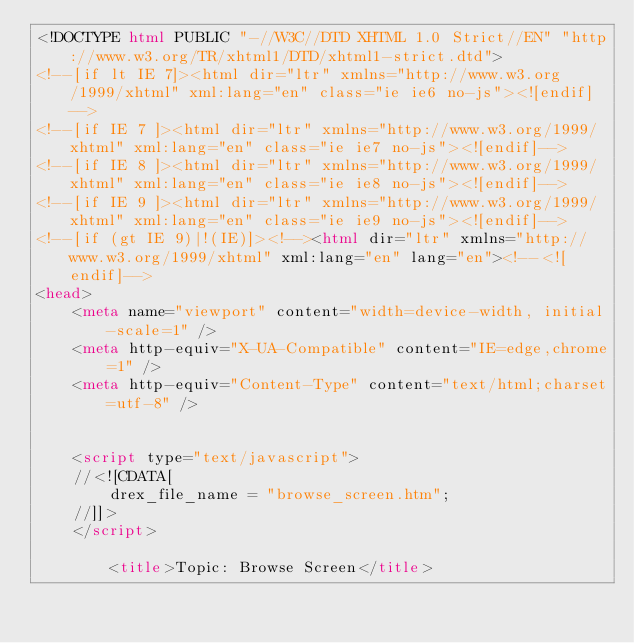Convert code to text. <code><loc_0><loc_0><loc_500><loc_500><_HTML_><!DOCTYPE html PUBLIC "-//W3C//DTD XHTML 1.0 Strict//EN" "http://www.w3.org/TR/xhtml1/DTD/xhtml1-strict.dtd">
<!--[if lt IE 7]><html dir="ltr" xmlns="http://www.w3.org/1999/xhtml" xml:lang="en" class="ie ie6 no-js"><![endif]-->
<!--[if IE 7 ]><html dir="ltr" xmlns="http://www.w3.org/1999/xhtml" xml:lang="en" class="ie ie7 no-js"><![endif]-->
<!--[if IE 8 ]><html dir="ltr" xmlns="http://www.w3.org/1999/xhtml" xml:lang="en" class="ie ie8 no-js"><![endif]-->
<!--[if IE 9 ]><html dir="ltr" xmlns="http://www.w3.org/1999/xhtml" xml:lang="en" class="ie ie9 no-js"><![endif]-->
<!--[if (gt IE 9)|!(IE)]><!--><html dir="ltr" xmlns="http://www.w3.org/1999/xhtml" xml:lang="en" lang="en"><!--<![endif]-->
<head>
    <meta name="viewport" content="width=device-width, initial-scale=1" />
    <meta http-equiv="X-UA-Compatible" content="IE=edge,chrome=1" />
    <meta http-equiv="Content-Type" content="text/html;charset=utf-8" />


    <script type="text/javascript">
    //<![CDATA[
        drex_file_name = "browse_screen.htm";
    //]]>
    </script>

    		<title>Topic: Browse Screen</title>
</code> 